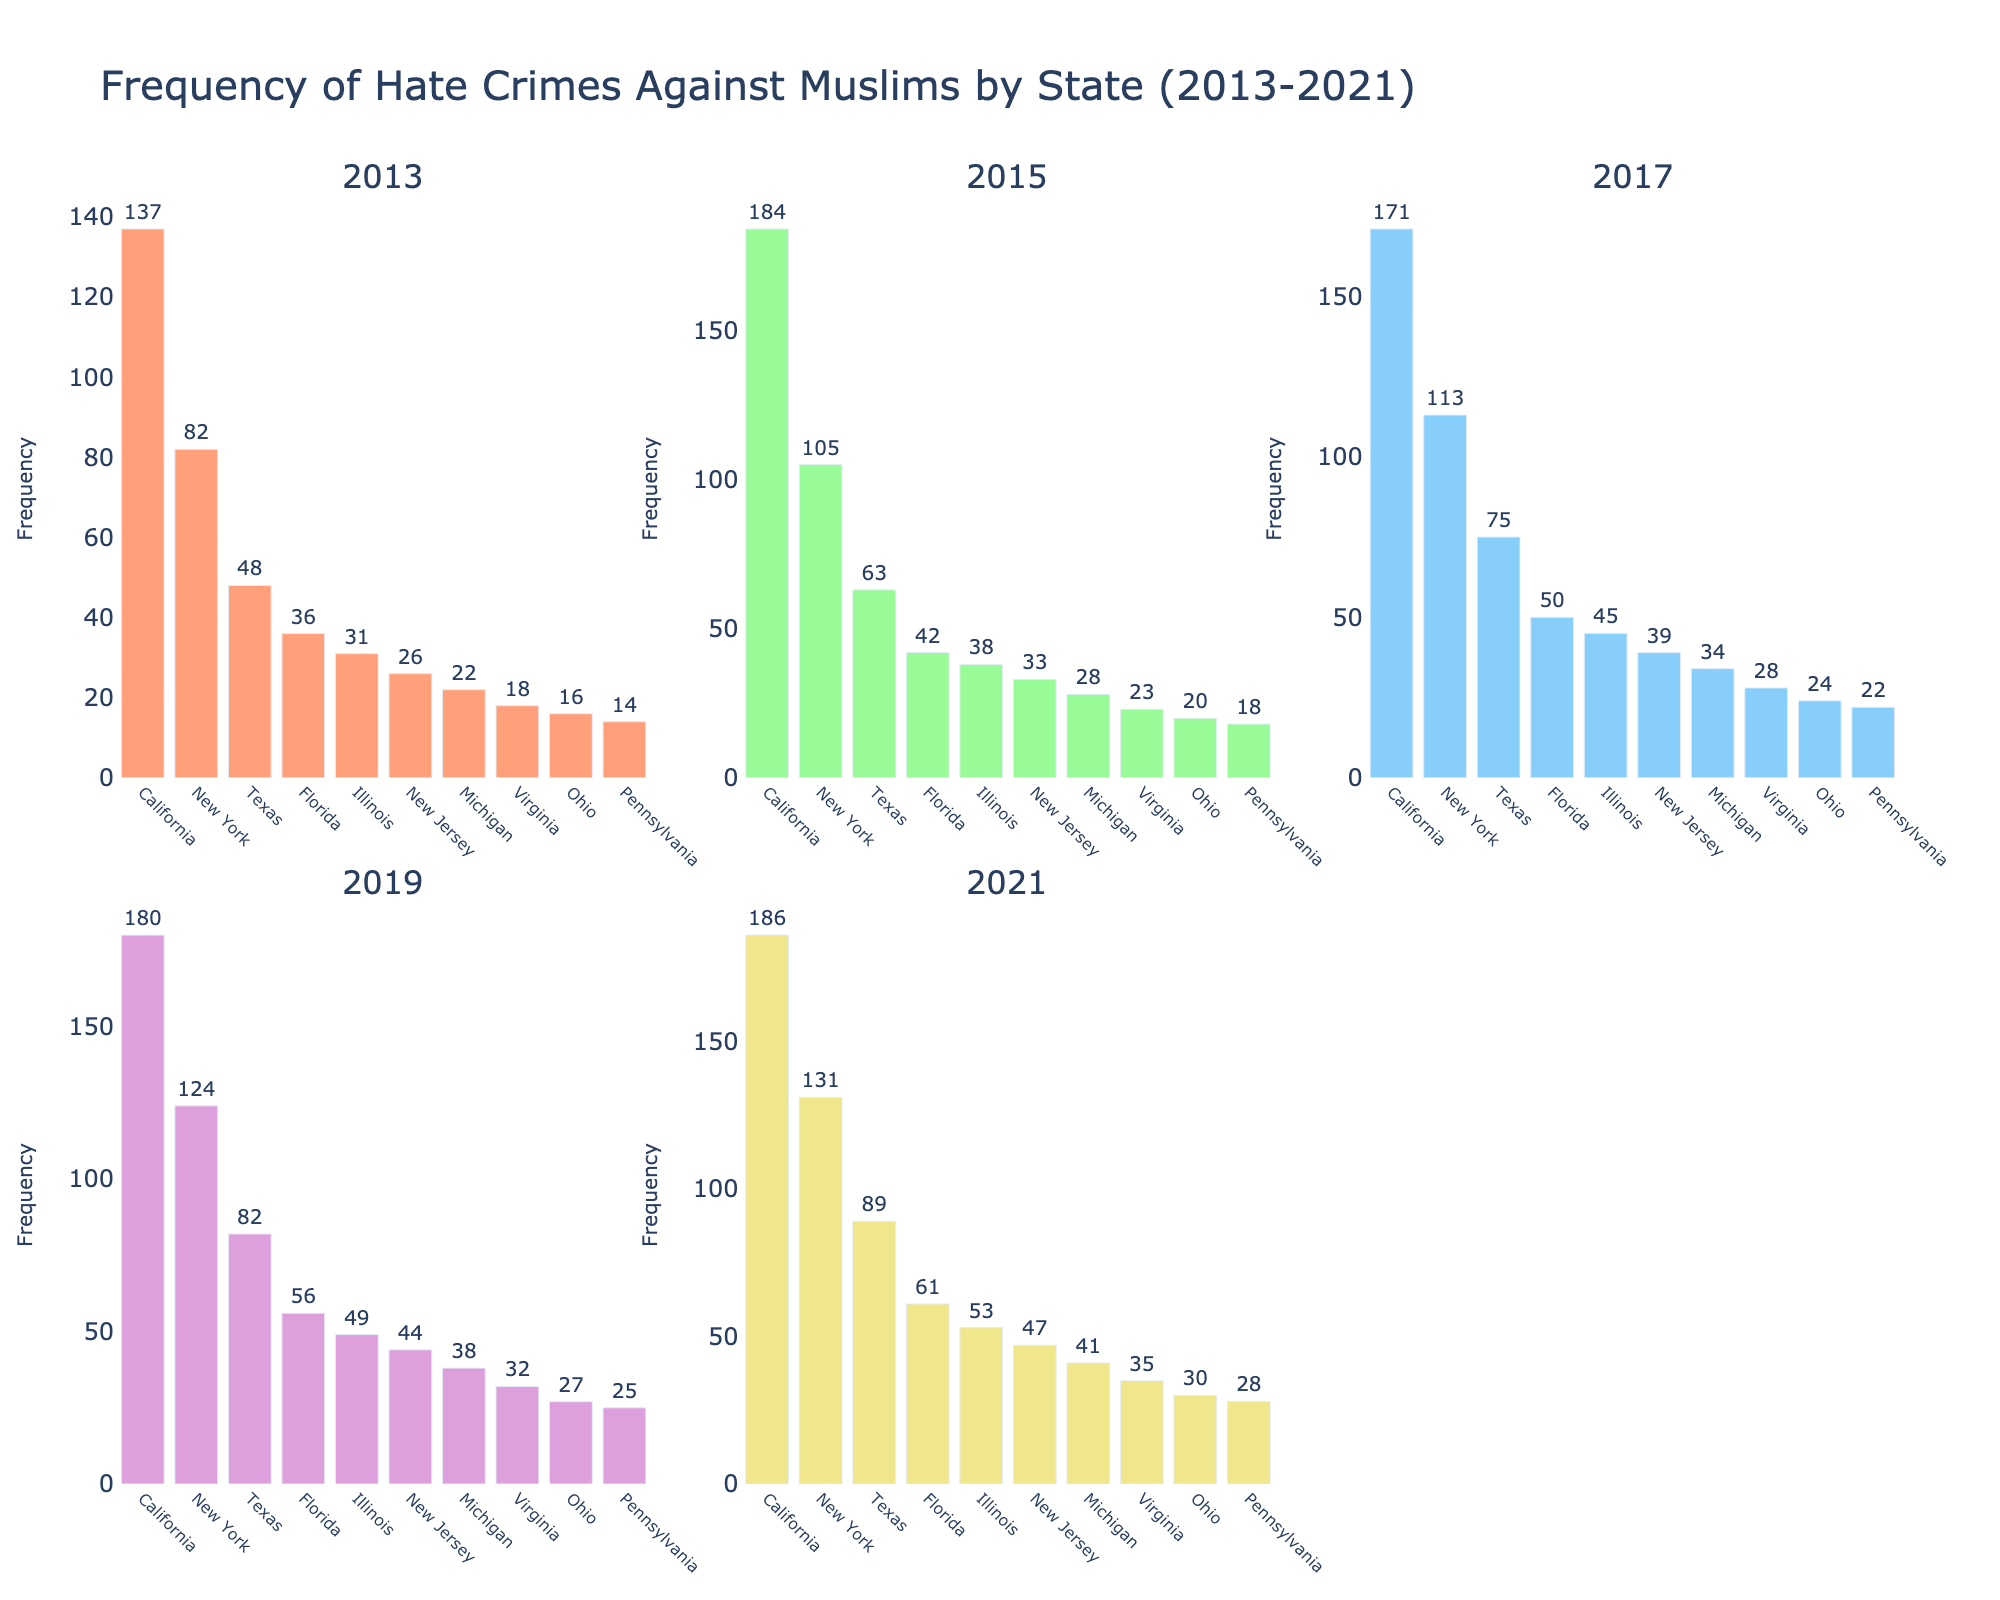What is the title of the figure? The title is displayed prominently at the top of the figure. It is "Evolution of Music Genre Popularity in the US (1960-2023)".
Answer: Evolution of Music Genre Popularity in the US (1960-2023) How many genres are displayed in the subplots? Each subplot corresponds to one genre, and there are 5 subplot titles. Therefore, there are 5 genres displayed.
Answer: 5 Which genre has shown a consistent increase in popularity from 1960 to 2023? By examining the trend lines in the subplots, Hip-Hop is the only genre that shows a consistent increase in popularity over the years.
Answer: Hip-Hop In which year did Rock's popularity peak, and what was the percentage? Looking at the Rock subplot, the highest point on the trendline is around 1970, where the percentage is 45%.
Answer: 1970, 45% What is the difference in popularity between Pop and Country in 1980? In the 1980 subplots for Pop and Country, the Pop percentage is 25% and the Country percentage is 20%. The difference is 25% - 20% = 5%.
Answer: 5% Which genre had the lowest popularity in 2023, and what was the percentage? In the 2023 subplots, R&B shows the lowest value, which is 2%.
Answer: R&B, 2% How did the popularity of Pop change from 1960 to 1990? In the Pop subplot, the percentage in 1960 was 30%. By 1990, it rose to 30%. The change was 30% - 30% = 0%.
Answer: 0% Between which two consecutive decades did Hip-Hop see the largest increase in popularity? By examining the Hip-Hop subplot, the largest increase is between 2000 (14%) and 2010 (25%). The increase is 25% - 14% = 11%.
Answer: 2000 to 2010 Which genre's popularity declined the most between 1970 and 1980? By comparing the subplots, Rock dropped from 45% in 1970 to 38% in 1980. The decline is 45% - 38% = 7%, which is the highest decline among genres.
Answer: Rock What is the average popularity of R&B from 1960 to 2023? Adding the R&B percentages and dividing by the number of years, we find (20+18+15+14+12+10+8+7+6+5+4+3+2+2) / 14 = 7.79%.
Answer: 7.79% 